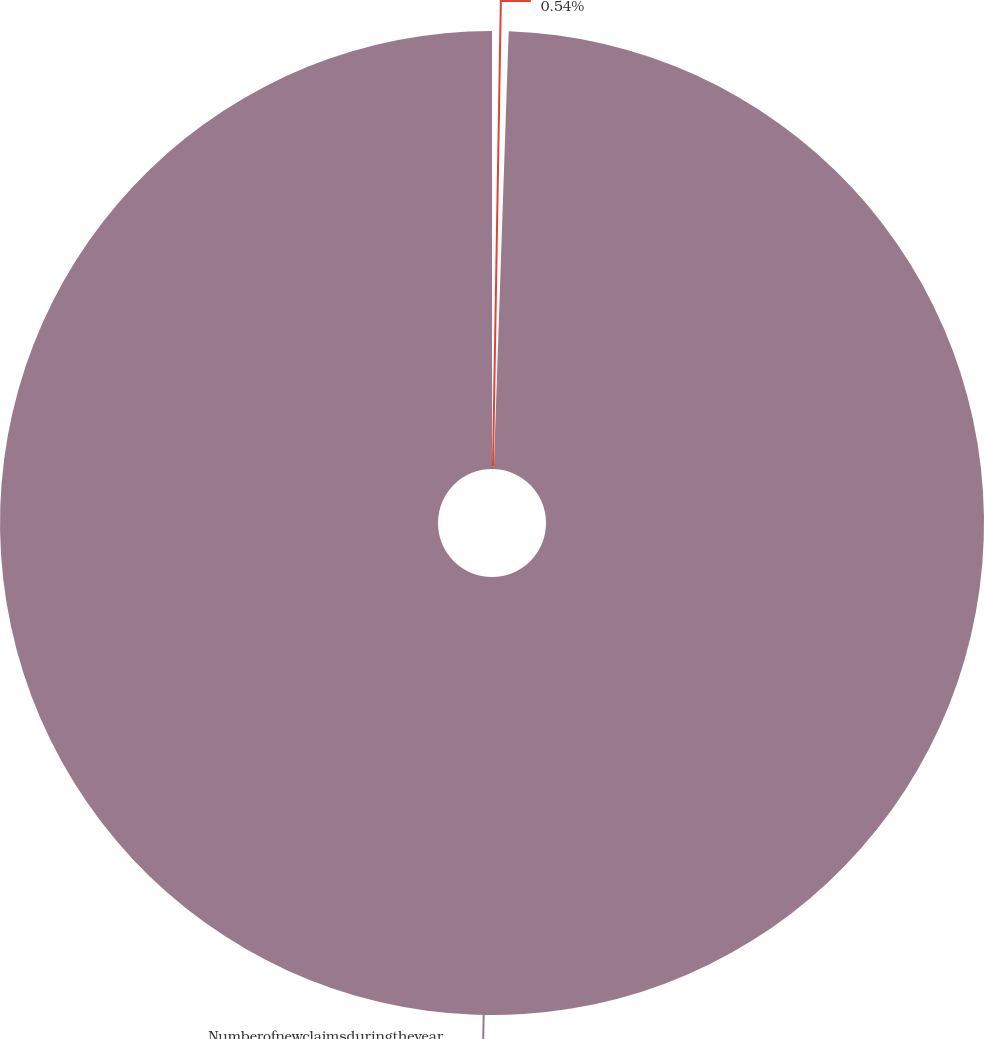<chart> <loc_0><loc_0><loc_500><loc_500><pie_chart><ecel><fcel>Numberofnewclaimsduringtheyear<nl><fcel>0.54%<fcel>99.46%<nl></chart> 